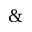Convert formula to latex. <formula><loc_0><loc_0><loc_500><loc_500>\&</formula> 